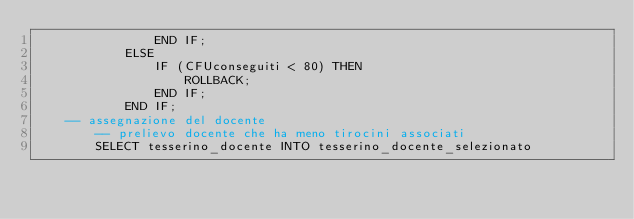Convert code to text. <code><loc_0><loc_0><loc_500><loc_500><_SQL_>                END IF; 
            ELSE
                IF (CFUconseguiti < 80) THEN
                    ROLLBACK;
                END IF; 
            END IF;
    -- assegnazione del docente
        -- prelievo docente che ha meno tirocini associati
        SELECT tesserino_docente INTO tesserino_docente_selezionato</code> 